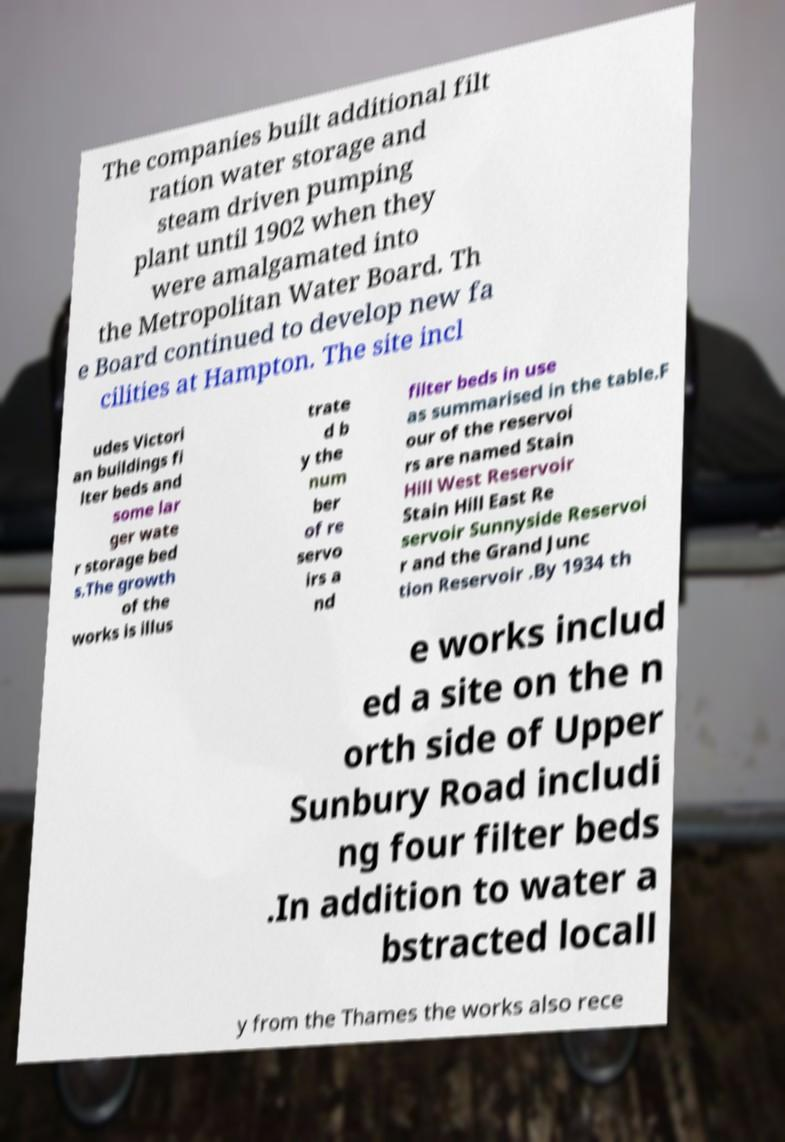For documentation purposes, I need the text within this image transcribed. Could you provide that? The companies built additional filt ration water storage and steam driven pumping plant until 1902 when they were amalgamated into the Metropolitan Water Board. Th e Board continued to develop new fa cilities at Hampton. The site incl udes Victori an buildings fi lter beds and some lar ger wate r storage bed s.The growth of the works is illus trate d b y the num ber of re servo irs a nd filter beds in use as summarised in the table.F our of the reservoi rs are named Stain Hill West Reservoir Stain Hill East Re servoir Sunnyside Reservoi r and the Grand Junc tion Reservoir .By 1934 th e works includ ed a site on the n orth side of Upper Sunbury Road includi ng four filter beds .In addition to water a bstracted locall y from the Thames the works also rece 